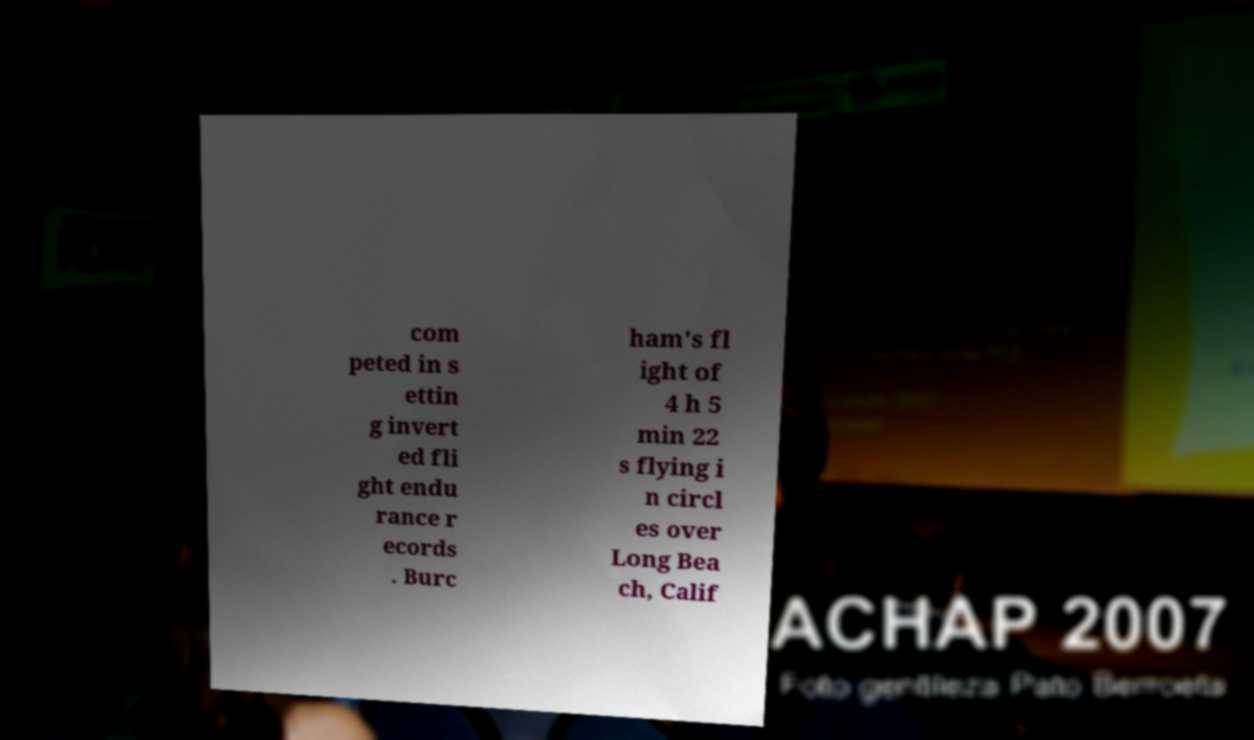Please read and relay the text visible in this image. What does it say? com peted in s ettin g invert ed fli ght endu rance r ecords . Burc ham's fl ight of 4 h 5 min 22 s flying i n circl es over Long Bea ch, Calif 